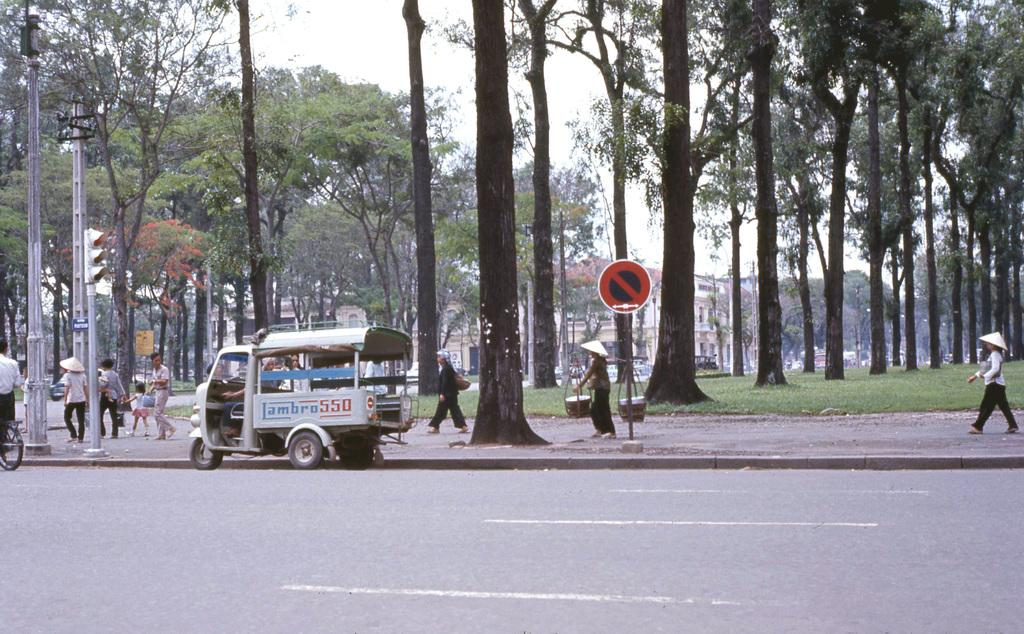How many people are in the image? There are persons in the image, but the exact number is not specified. What objects can be seen in the image besides the persons? There are poles, a vehicle, and sign boards visible in the image. What can be seen in the background of the image? Trees, grass, buildings, and the sky are visible in the background of the image. How many bears are visible in the image? There are no bears present in the image. What type of cactus can be seen growing near the poles in the image? There is no cactus present in the image; the background features trees and grass instead. 